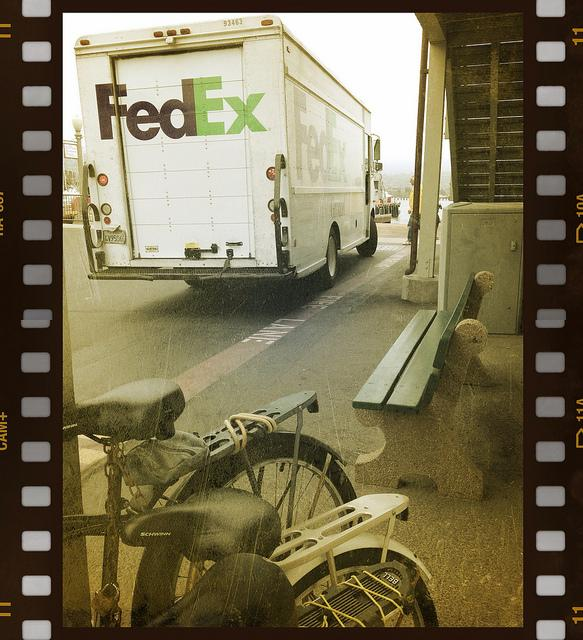What type of business is the truck for?

Choices:
A) refrigerated items
B) food truck
C) delivering packages
D) gas delivery delivering packages 